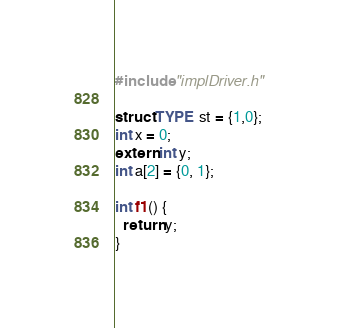Convert code to text. <code><loc_0><loc_0><loc_500><loc_500><_C_>#include "implDriver.h"

struct TYPE st = {1,0};
int x = 0;
extern int y;
int a[2] = {0, 1};

int f1() {
  return y;
}
</code> 